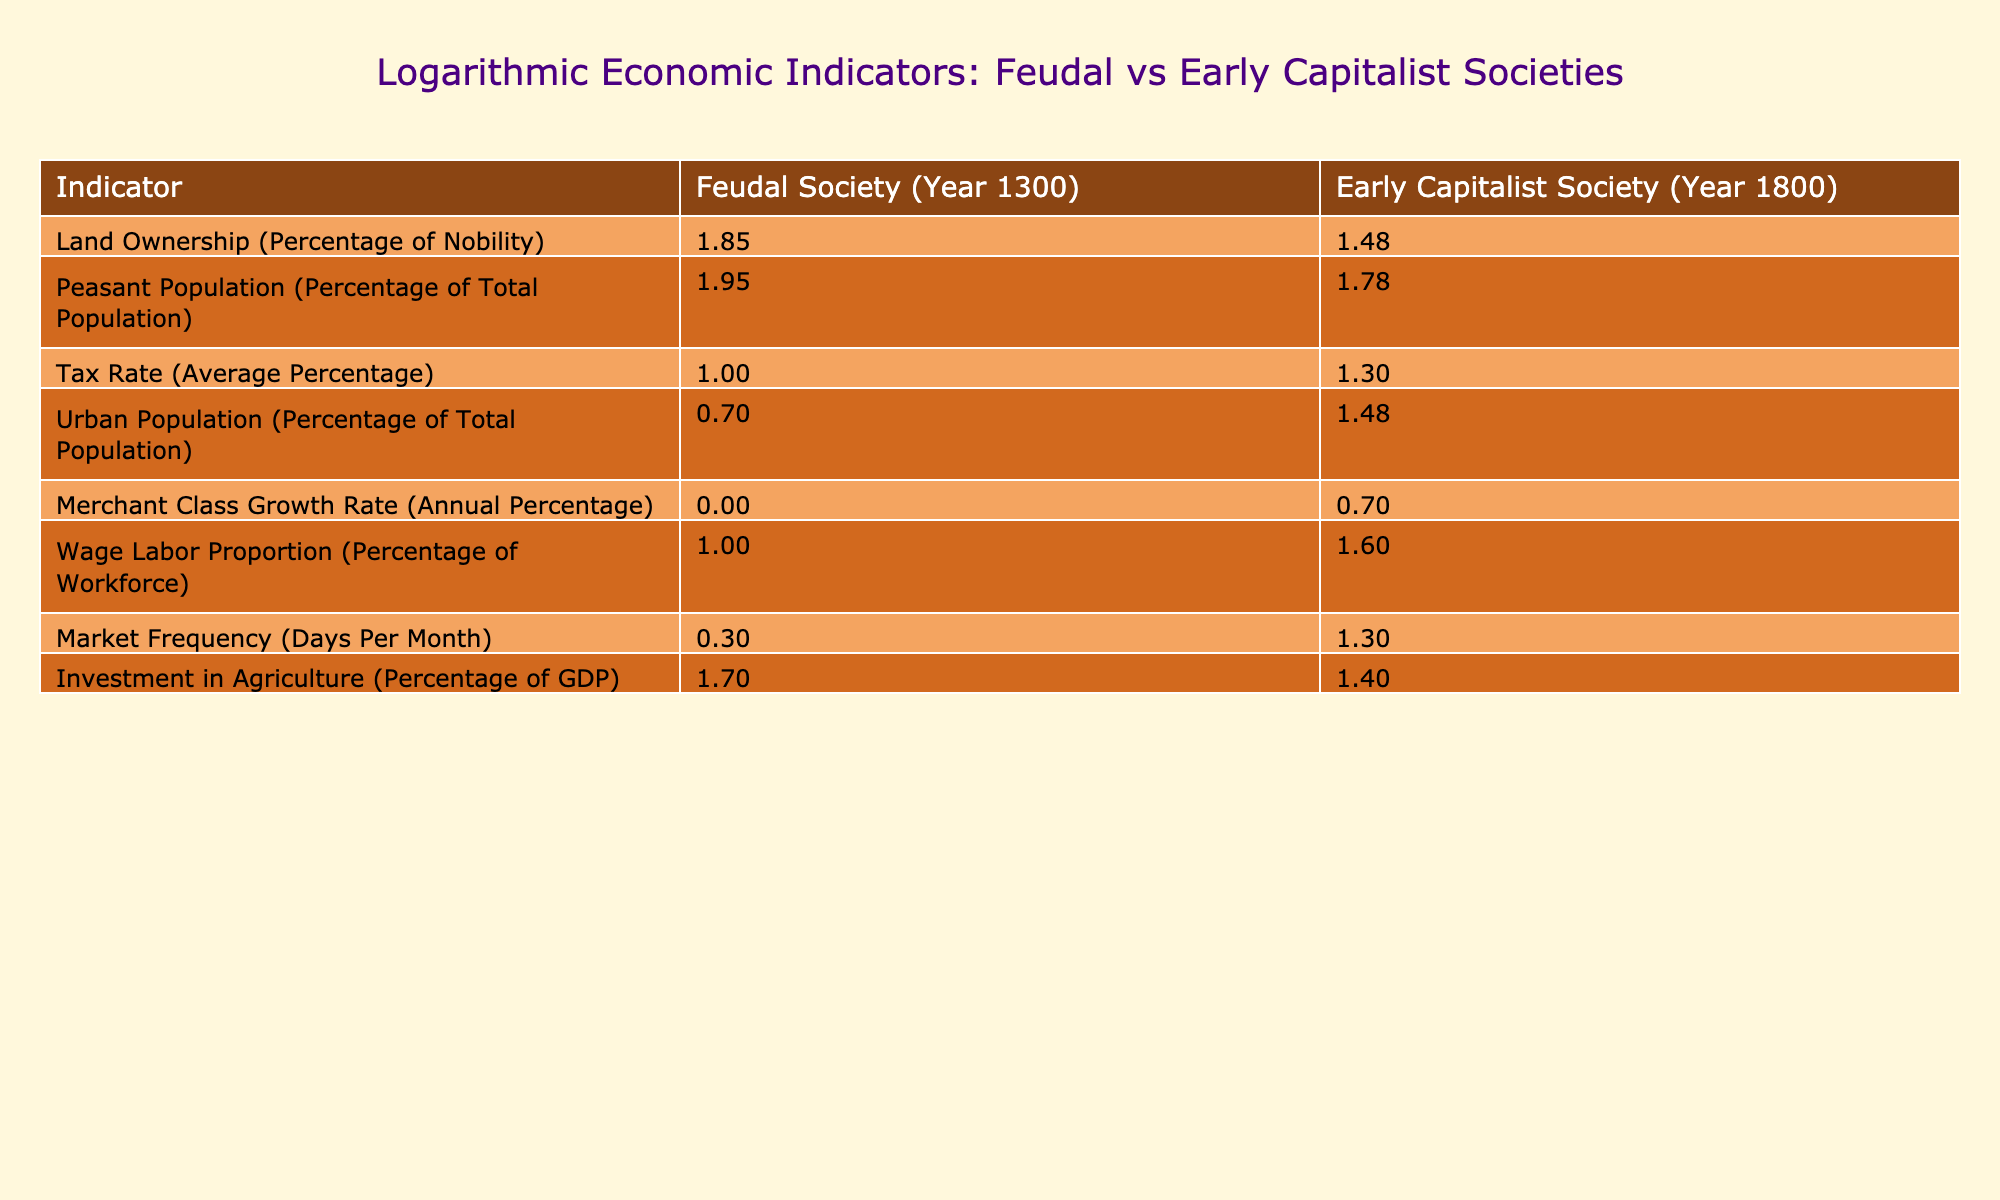What is the percentage of land ownership by the nobility in feudal society? According to the table, the land ownership by the nobility in a feudal society in the year 1300 is listed as 70%.
Answer: 70% What is the average tax rate in early capitalist society? In the table, the average tax rate is provided for the early capitalist society in the year 1800, which is 20%.
Answer: 20% In which society was the peasant population higher, feudal or early capitalist? The peasant population is 90% in the feudal society (1300) and 60% in the early capitalist society (1800). Since 90% is greater than 60%, the peasant population was higher in the feudal society.
Answer: Feudal society What is the difference in the wage labor proportion between the two societies? The wage labor proportion in the feudal society is 10%, while in the early capitalist society it is 40%. The difference can be calculated as 40% - 10% = 30%.
Answer: 30% Was the urban population larger in the early capitalist society compared to the feudal society? In the table, the urban population is 5% in the feudal society and 30% in the early capitalist society. Since 30% is larger than 5%, the urban population was indeed larger in the early capitalist society.
Answer: Yes What is the ratio of the merchant class growth rate between the early capitalist and feudal societies? The merchant class growth rate is 1% for the feudal society and 5% for the early capitalist society. The ratio can be calculated as 5% / 1% = 5. Therefore, the ratio is 5:1.
Answer: 5:1 What percentage of the workforce in early capitalist society is engaged in wage labor? In the early capitalist society, the wage labor proportion is given as 40%.
Answer: 40% If we sum the urban population percentages from both societies, what do we get? The urban population in the feudal society is 5% and in the early capitalist society it is 30%. Summing them gives us 5% + 30% = 35%.
Answer: 35% Does investment in agriculture represent a larger percentage of GDP in feudal society than in early capitalist society? The investment in agriculture is 50% of GDP in the feudal society and 25% in the early capitalist society. Since 50% is greater than 25%, investment in agriculture is larger in the feudal society.
Answer: Yes 